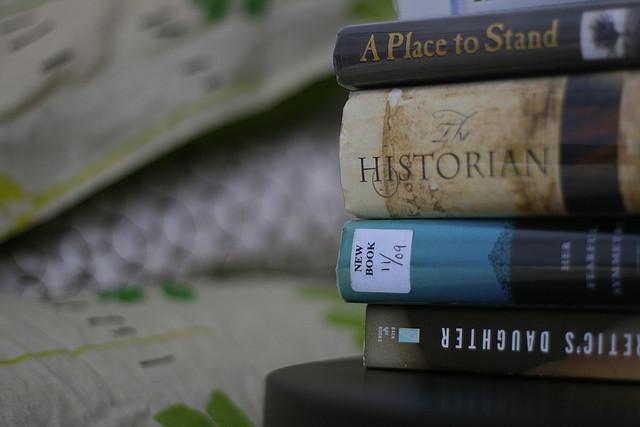What is the title of the top book?
Keep it brief. A place to stand. Are these library books?
Answer briefly. Yes. Are these books for a college student?
Short answer required. Yes. 